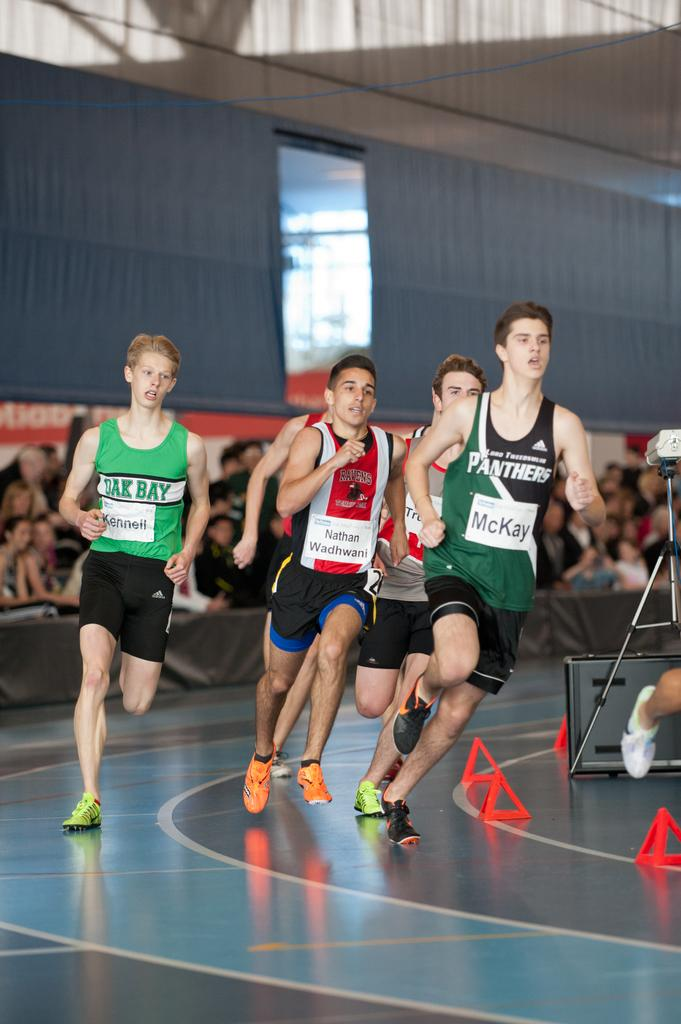What type of structure is shown in the picture? There is an indoor stadium in the picture. What are the people in the stadium doing? There are people running in the stadium. How many people can be seen in the stadium? There are many people present in the stadium. What type of seed can be seen growing in the cave in the image? There is no cave or seed present in the image; it features an indoor stadium with people running. 